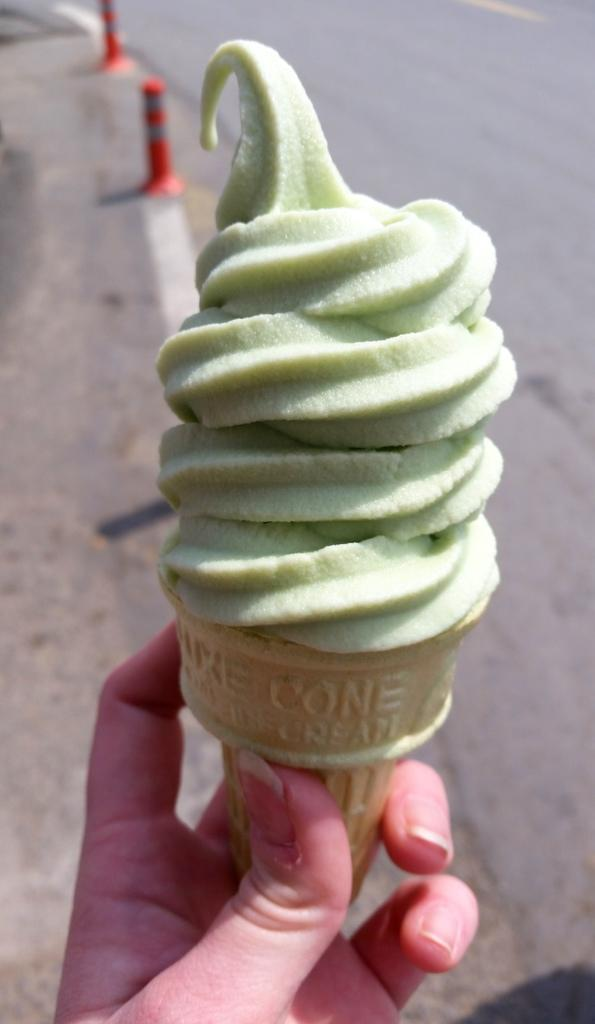What is the main subject in the foreground of the image? There is a person in the foreground of the image. What is the person holding in the image? The person is holding an ice cream. What can be seen in the background of the image? There is a road and two barricades in the background of the image. Can you see a flame coming from the ice cream in the image? No, there is no flame present in the image. 